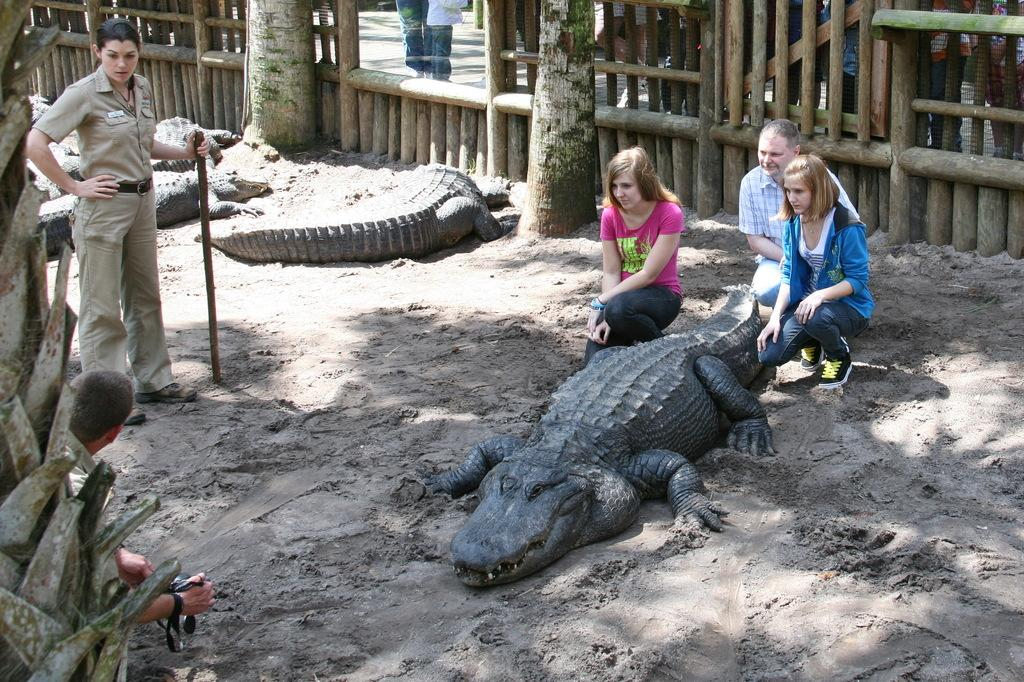What types of living organisms can be seen in the image? People and crocodiles are visible in the image. What type of vegetation is present in the image? Trees are present in the image. What kind of barrier can be seen in the image? There is a wooden fence in the image. Where is the man located in the image? The man is visible in the left side of the image. What is the man holding in the image? The man is holding a camera. What type of account is the man trying to open in the image? There is no indication in the image that the man is trying to open an account, so it cannot be determined from the picture. 